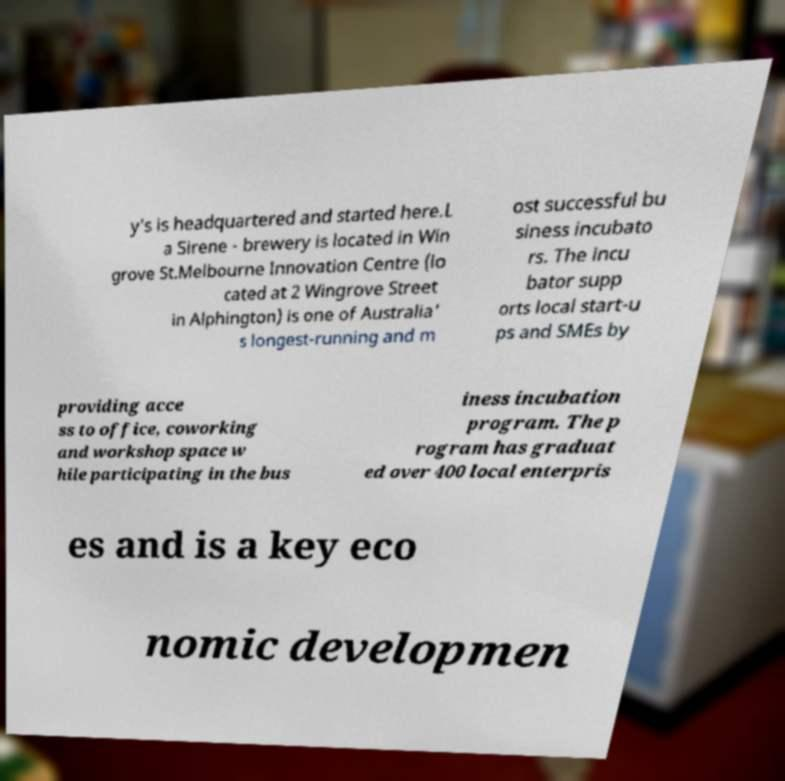Can you accurately transcribe the text from the provided image for me? y's is headquartered and started here.L a Sirene - brewery is located in Win grove St.Melbourne Innovation Centre (lo cated at 2 Wingrove Street in Alphington) is one of Australia' s longest-running and m ost successful bu siness incubato rs. The incu bator supp orts local start-u ps and SMEs by providing acce ss to office, coworking and workshop space w hile participating in the bus iness incubation program. The p rogram has graduat ed over 400 local enterpris es and is a key eco nomic developmen 